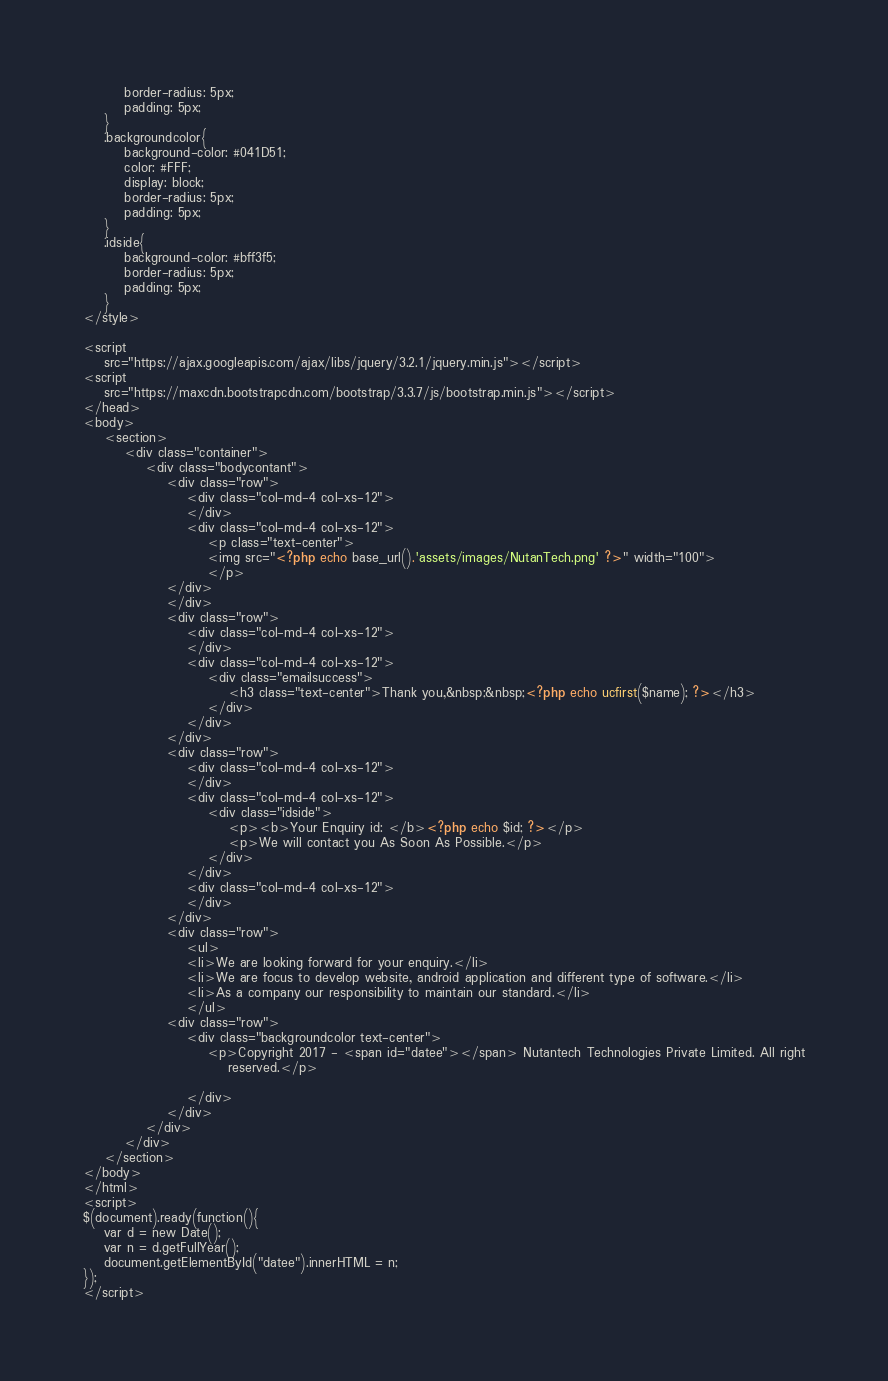<code> <loc_0><loc_0><loc_500><loc_500><_PHP_>		border-radius: 5px;
		padding: 5px;
	}
	.backgroundcolor{
		background-color: #041D51;
		color: #FFF;
		display: block;
		border-radius: 5px;
		padding: 5px;
	}
	.idside{
		background-color: #bff3f5;
		border-radius: 5px;
		padding: 5px;
	}
</style>

<script
	src="https://ajax.googleapis.com/ajax/libs/jquery/3.2.1/jquery.min.js"></script>
<script
	src="https://maxcdn.bootstrapcdn.com/bootstrap/3.3.7/js/bootstrap.min.js"></script>
</head>
<body>
	<section>
		<div class="container">
			<div class="bodycontant">
				<div class="row">
					<div class="col-md-4 col-xs-12">
					</div>
					<div class="col-md-4 col-xs-12">
						<p class="text-center">
						<img src="<?php echo base_url().'assets/images/NutanTech.png' ?>" width="100">
						</p>
				</div>
				</div>
				<div class="row">
					<div class="col-md-4 col-xs-12">
					</div>
					<div class="col-md-4 col-xs-12">
						<div class="emailsuccess">
							<h3 class="text-center">Thank you,&nbsp;&nbsp;<?php echo ucfirst($name); ?></h3>
						</div>
					</div>
				</div>
				<div class="row">
					<div class="col-md-4 col-xs-12">
					</div>
					<div class="col-md-4 col-xs-12">
						<div class="idside">
							<p><b>Your Enquiry id: </b><?php echo $id; ?></p>
							<p>We will contact you As Soon As Possible.</p>
						</div>
					</div>
					<div class="col-md-4 col-xs-12">
					</div>
				</div>
				<div class="row">
					<ul>
					<li>We are looking forward for your enquiry.</li>
					<li>We are focus to develop website, android application and different type of software.</li>
					<li>As a company our responsibility to maintain our standard.</li>
					</ul>
				<div class="row">
					<div class="backgroundcolor text-center">
						<p>Copyright 2017 - <span id="datee"></span> Nutantech Technologies Private Limited. All right
							reserved.</p>

					</div>
				</div>
			</div>
		</div>
	</section>
</body>
</html>
<script>
$(document).ready(function(){ 
    var d = new Date();
    var n = d.getFullYear();
    document.getElementById("datee").innerHTML = n;
});
</script></code> 